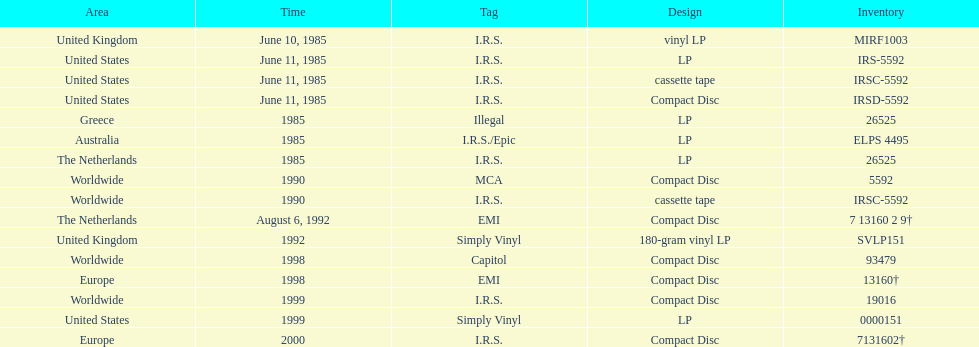What is the greatest consecutive amount of releases in lp format? 3. 